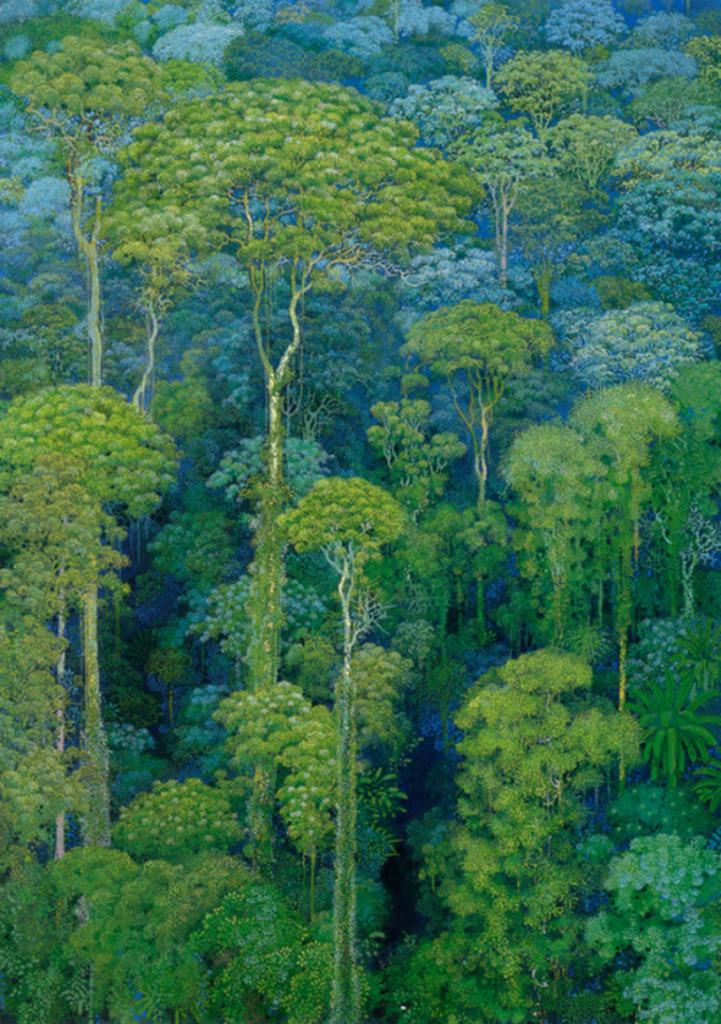What type of vegetation is shown in the image? The image depicts trees. What type of street is visible in the image? There is no street visible in the image; it only depicts trees. What type of pleasure can be derived from the image? The image is not intended to provide pleasure, but rather to showcase trees. 